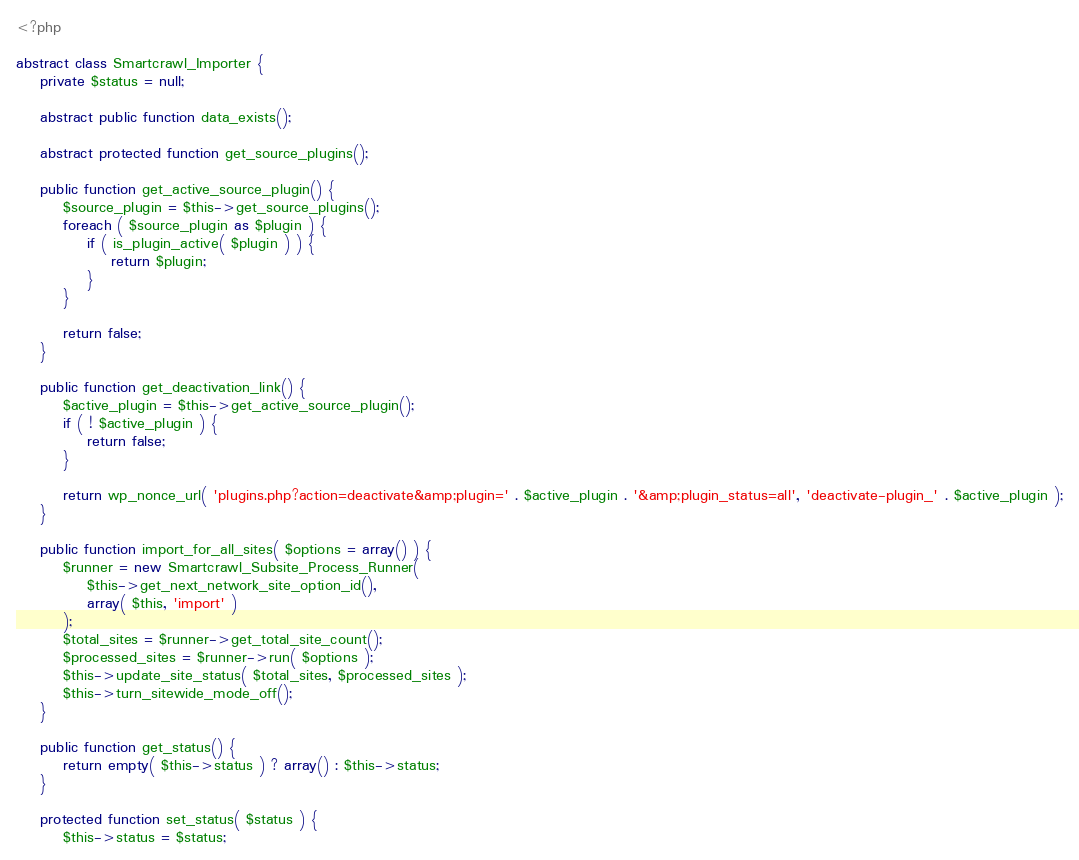Convert code to text. <code><loc_0><loc_0><loc_500><loc_500><_PHP_><?php

abstract class Smartcrawl_Importer {
	private $status = null;

	abstract public function data_exists();

	abstract protected function get_source_plugins();

	public function get_active_source_plugin() {
		$source_plugin = $this->get_source_plugins();
		foreach ( $source_plugin as $plugin ) {
			if ( is_plugin_active( $plugin ) ) {
				return $plugin;
			}
		}

		return false;
	}

	public function get_deactivation_link() {
		$active_plugin = $this->get_active_source_plugin();
		if ( ! $active_plugin ) {
			return false;
		}

		return wp_nonce_url( 'plugins.php?action=deactivate&amp;plugin=' . $active_plugin . '&amp;plugin_status=all', 'deactivate-plugin_' . $active_plugin );
	}

	public function import_for_all_sites( $options = array() ) {
		$runner = new Smartcrawl_Subsite_Process_Runner(
			$this->get_next_network_site_option_id(),
			array( $this, 'import' )
		);
		$total_sites = $runner->get_total_site_count();
		$processed_sites = $runner->run( $options );
		$this->update_site_status( $total_sites, $processed_sites );
		$this->turn_sitewide_mode_off();
	}

	public function get_status() {
		return empty( $this->status ) ? array() : $this->status;
	}

	protected function set_status( $status ) {
		$this->status = $status;</code> 